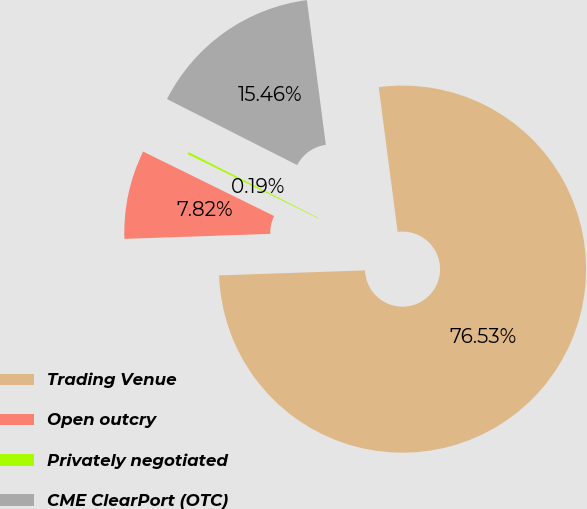<chart> <loc_0><loc_0><loc_500><loc_500><pie_chart><fcel>Trading Venue<fcel>Open outcry<fcel>Privately negotiated<fcel>CME ClearPort (OTC)<nl><fcel>76.53%<fcel>7.82%<fcel>0.19%<fcel>15.46%<nl></chart> 